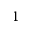<formula> <loc_0><loc_0><loc_500><loc_500>1</formula> 